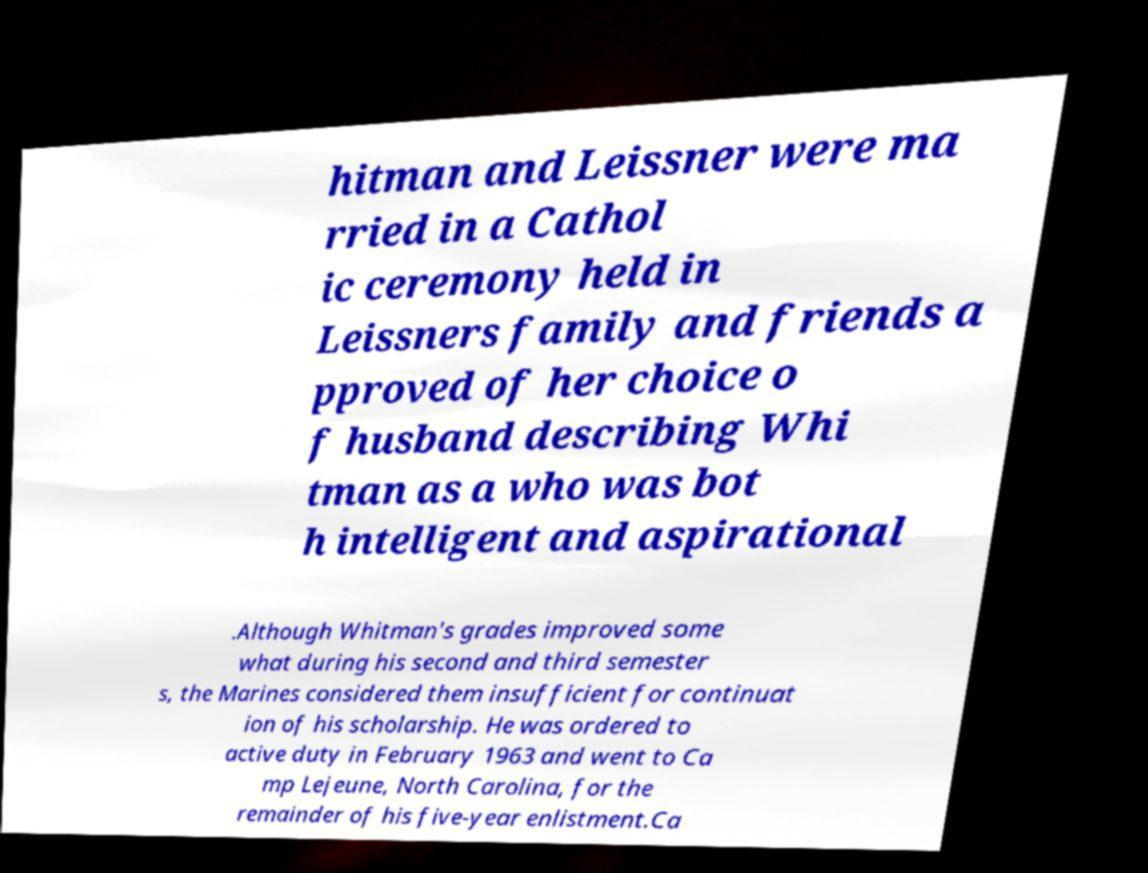Please identify and transcribe the text found in this image. hitman and Leissner were ma rried in a Cathol ic ceremony held in Leissners family and friends a pproved of her choice o f husband describing Whi tman as a who was bot h intelligent and aspirational .Although Whitman's grades improved some what during his second and third semester s, the Marines considered them insufficient for continuat ion of his scholarship. He was ordered to active duty in February 1963 and went to Ca mp Lejeune, North Carolina, for the remainder of his five-year enlistment.Ca 